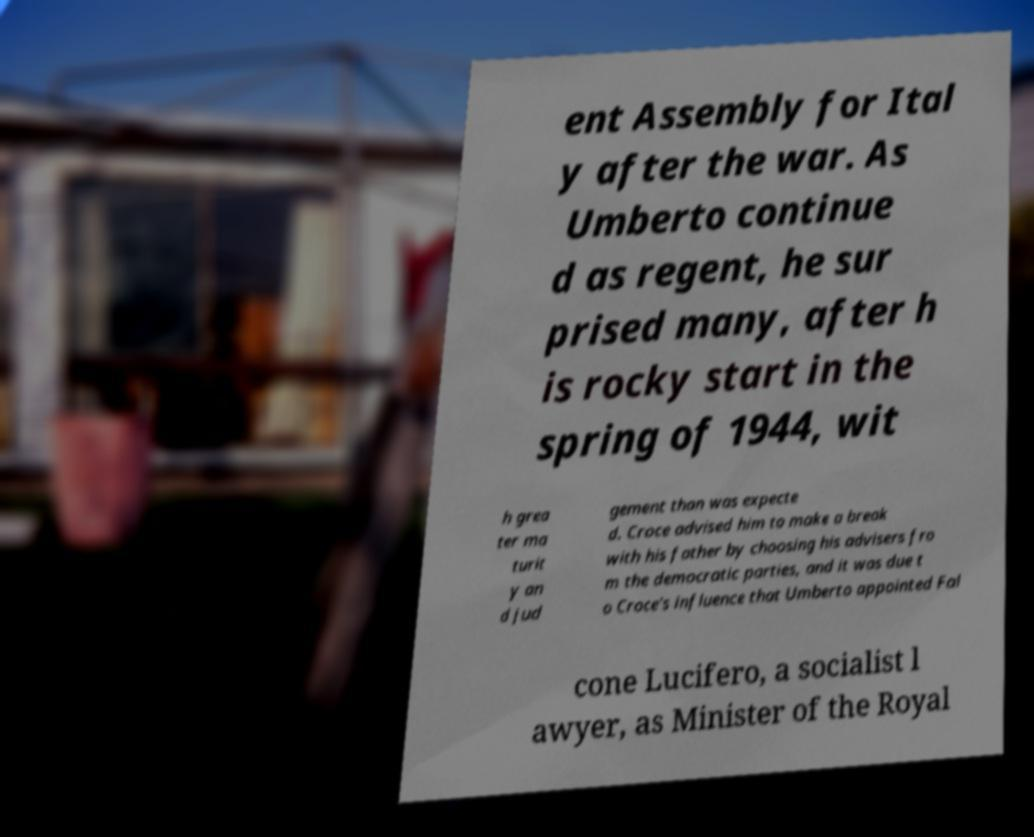Please read and relay the text visible in this image. What does it say? ent Assembly for Ital y after the war. As Umberto continue d as regent, he sur prised many, after h is rocky start in the spring of 1944, wit h grea ter ma turit y an d jud gement than was expecte d. Croce advised him to make a break with his father by choosing his advisers fro m the democratic parties, and it was due t o Croce's influence that Umberto appointed Fal cone Lucifero, a socialist l awyer, as Minister of the Royal 